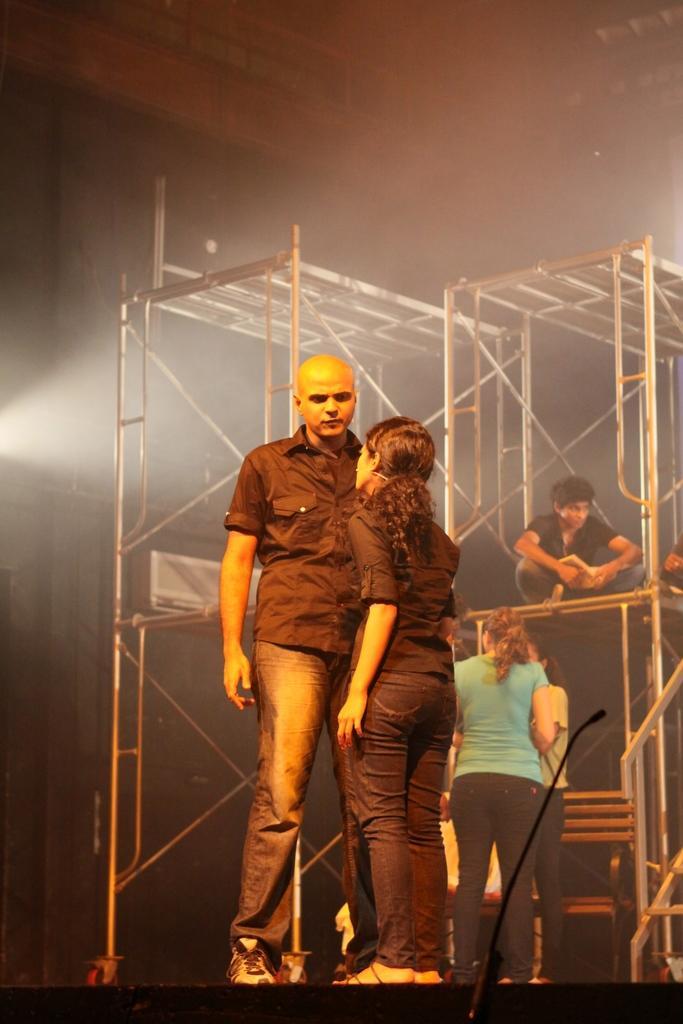In one or two sentences, can you explain what this image depicts? In this image we can see people, bench, mike, stands, and other objects. There is a dark background. 